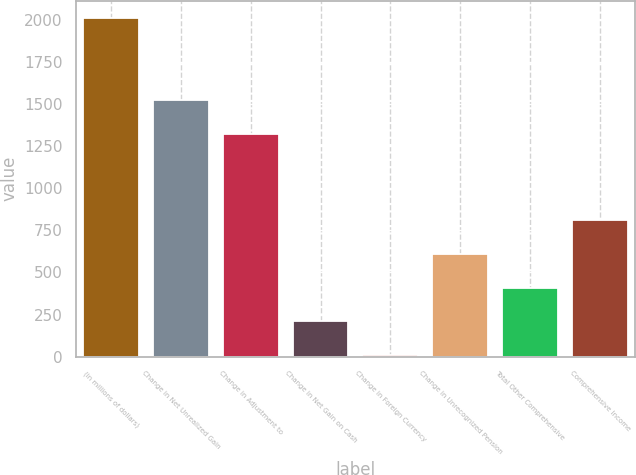Convert chart to OTSL. <chart><loc_0><loc_0><loc_500><loc_500><bar_chart><fcel>(in millions of dollars)<fcel>Change in Net Unrealized Gain<fcel>Change in Adjustment to<fcel>Change in Net Gain on Cash<fcel>Change in Foreign Currency<fcel>Change in Unrecognized Pension<fcel>Total Other Comprehensive<fcel>Comprehensive Income<nl><fcel>2011<fcel>1521.15<fcel>1321.1<fcel>210.55<fcel>10.5<fcel>610.65<fcel>410.6<fcel>810.7<nl></chart> 